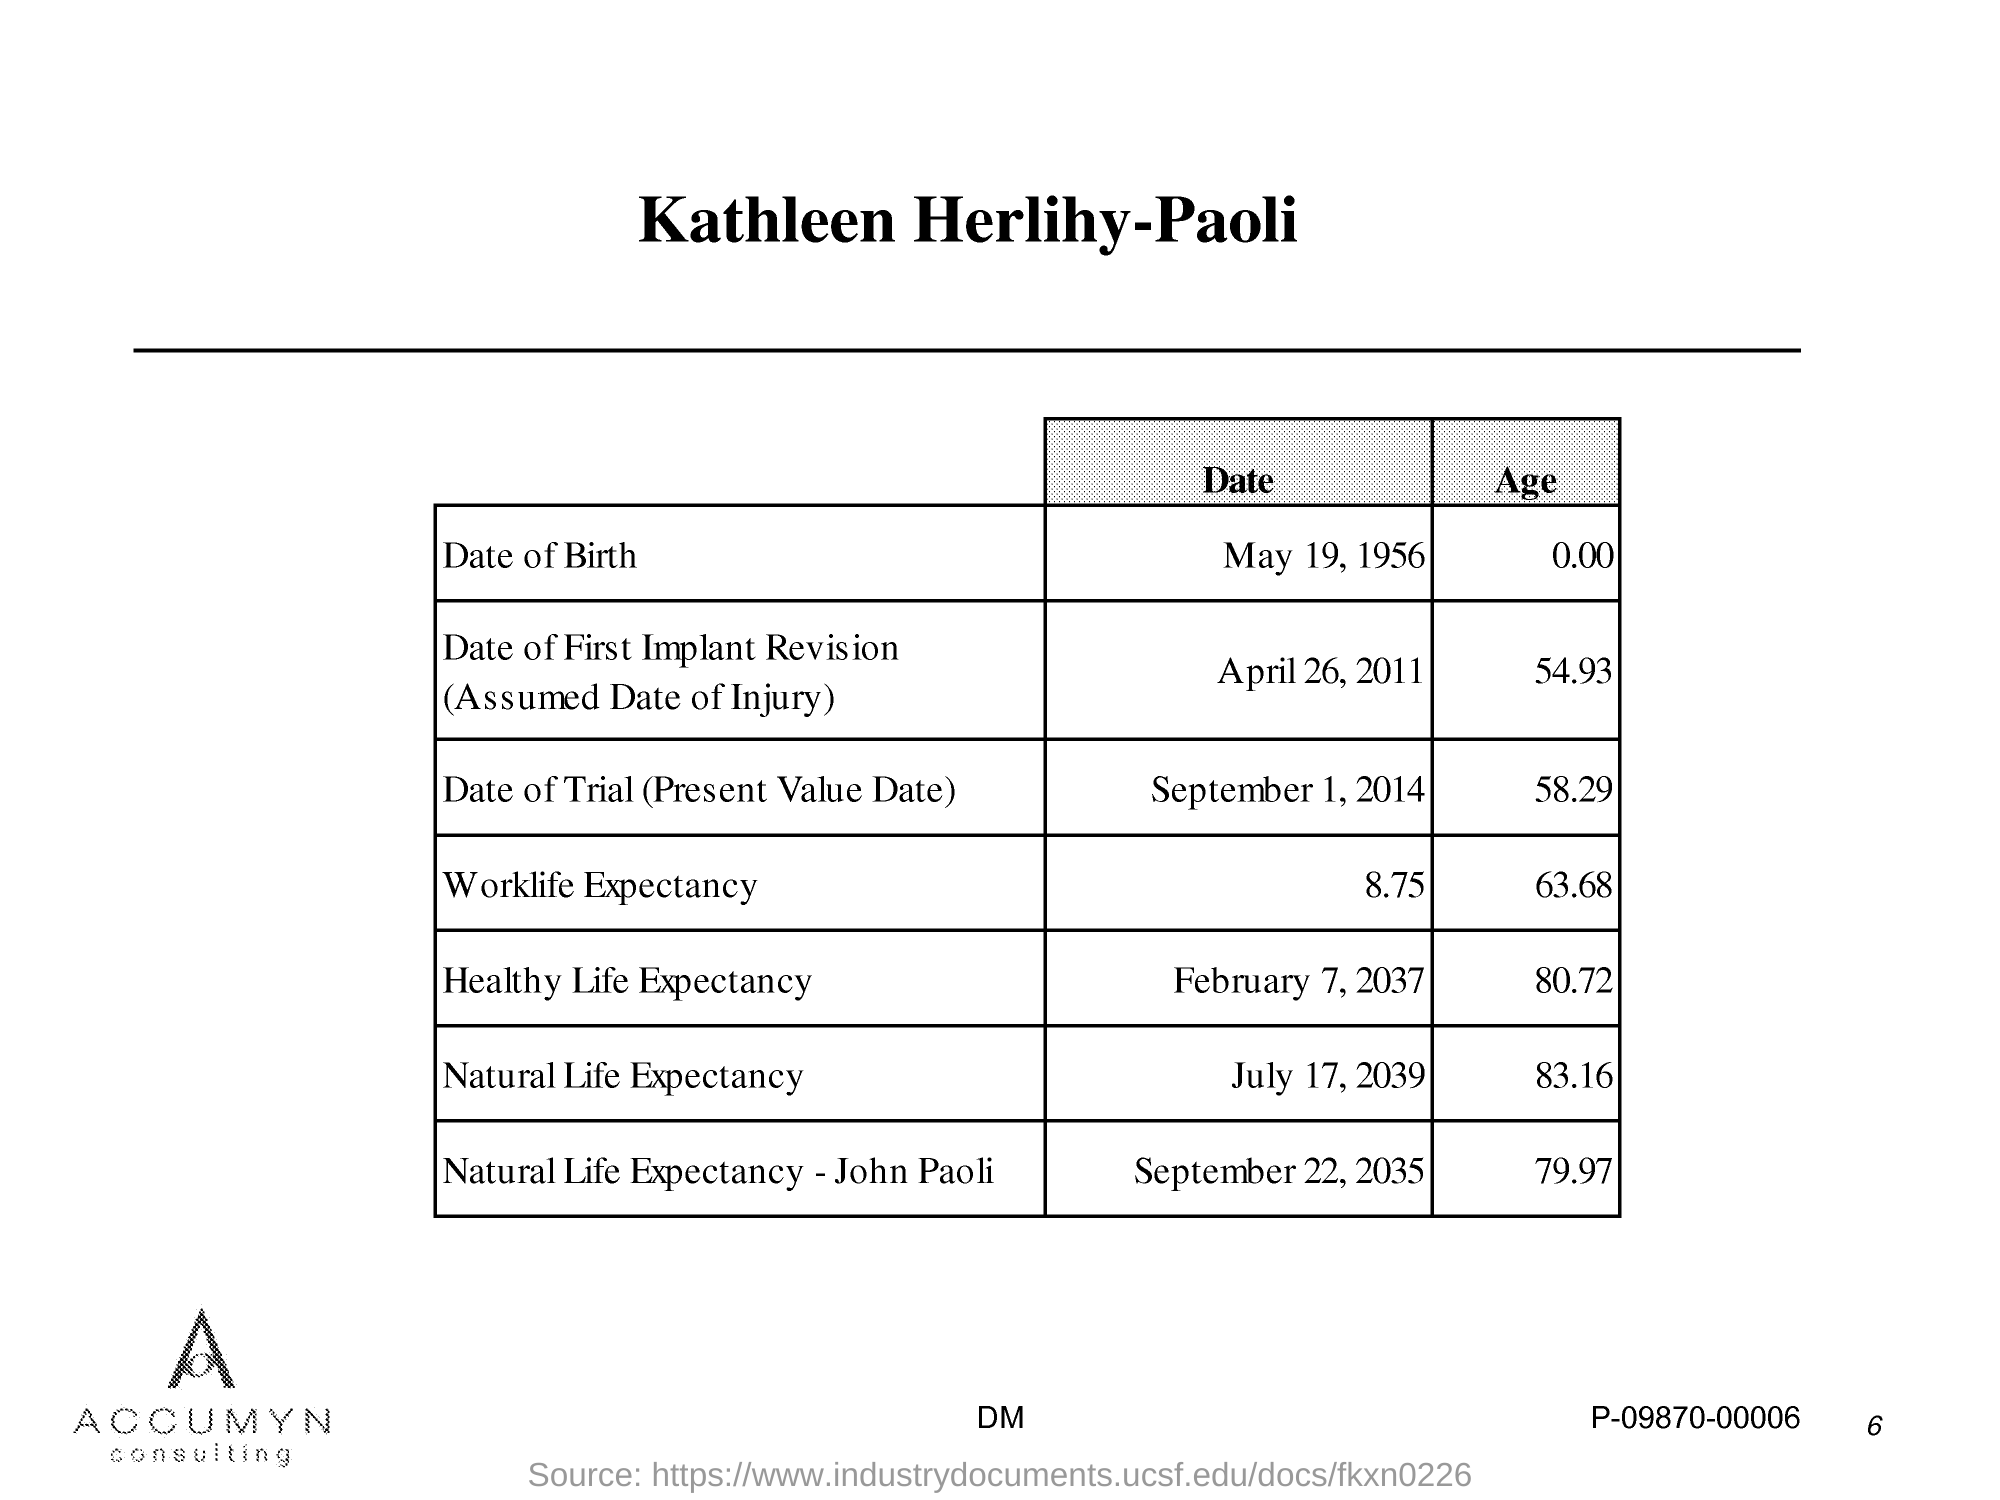Highlight a few significant elements in this photo. The title of the document is "What is the title of the document?" Kathleen Herlihy-Paoli is the author of this document. 